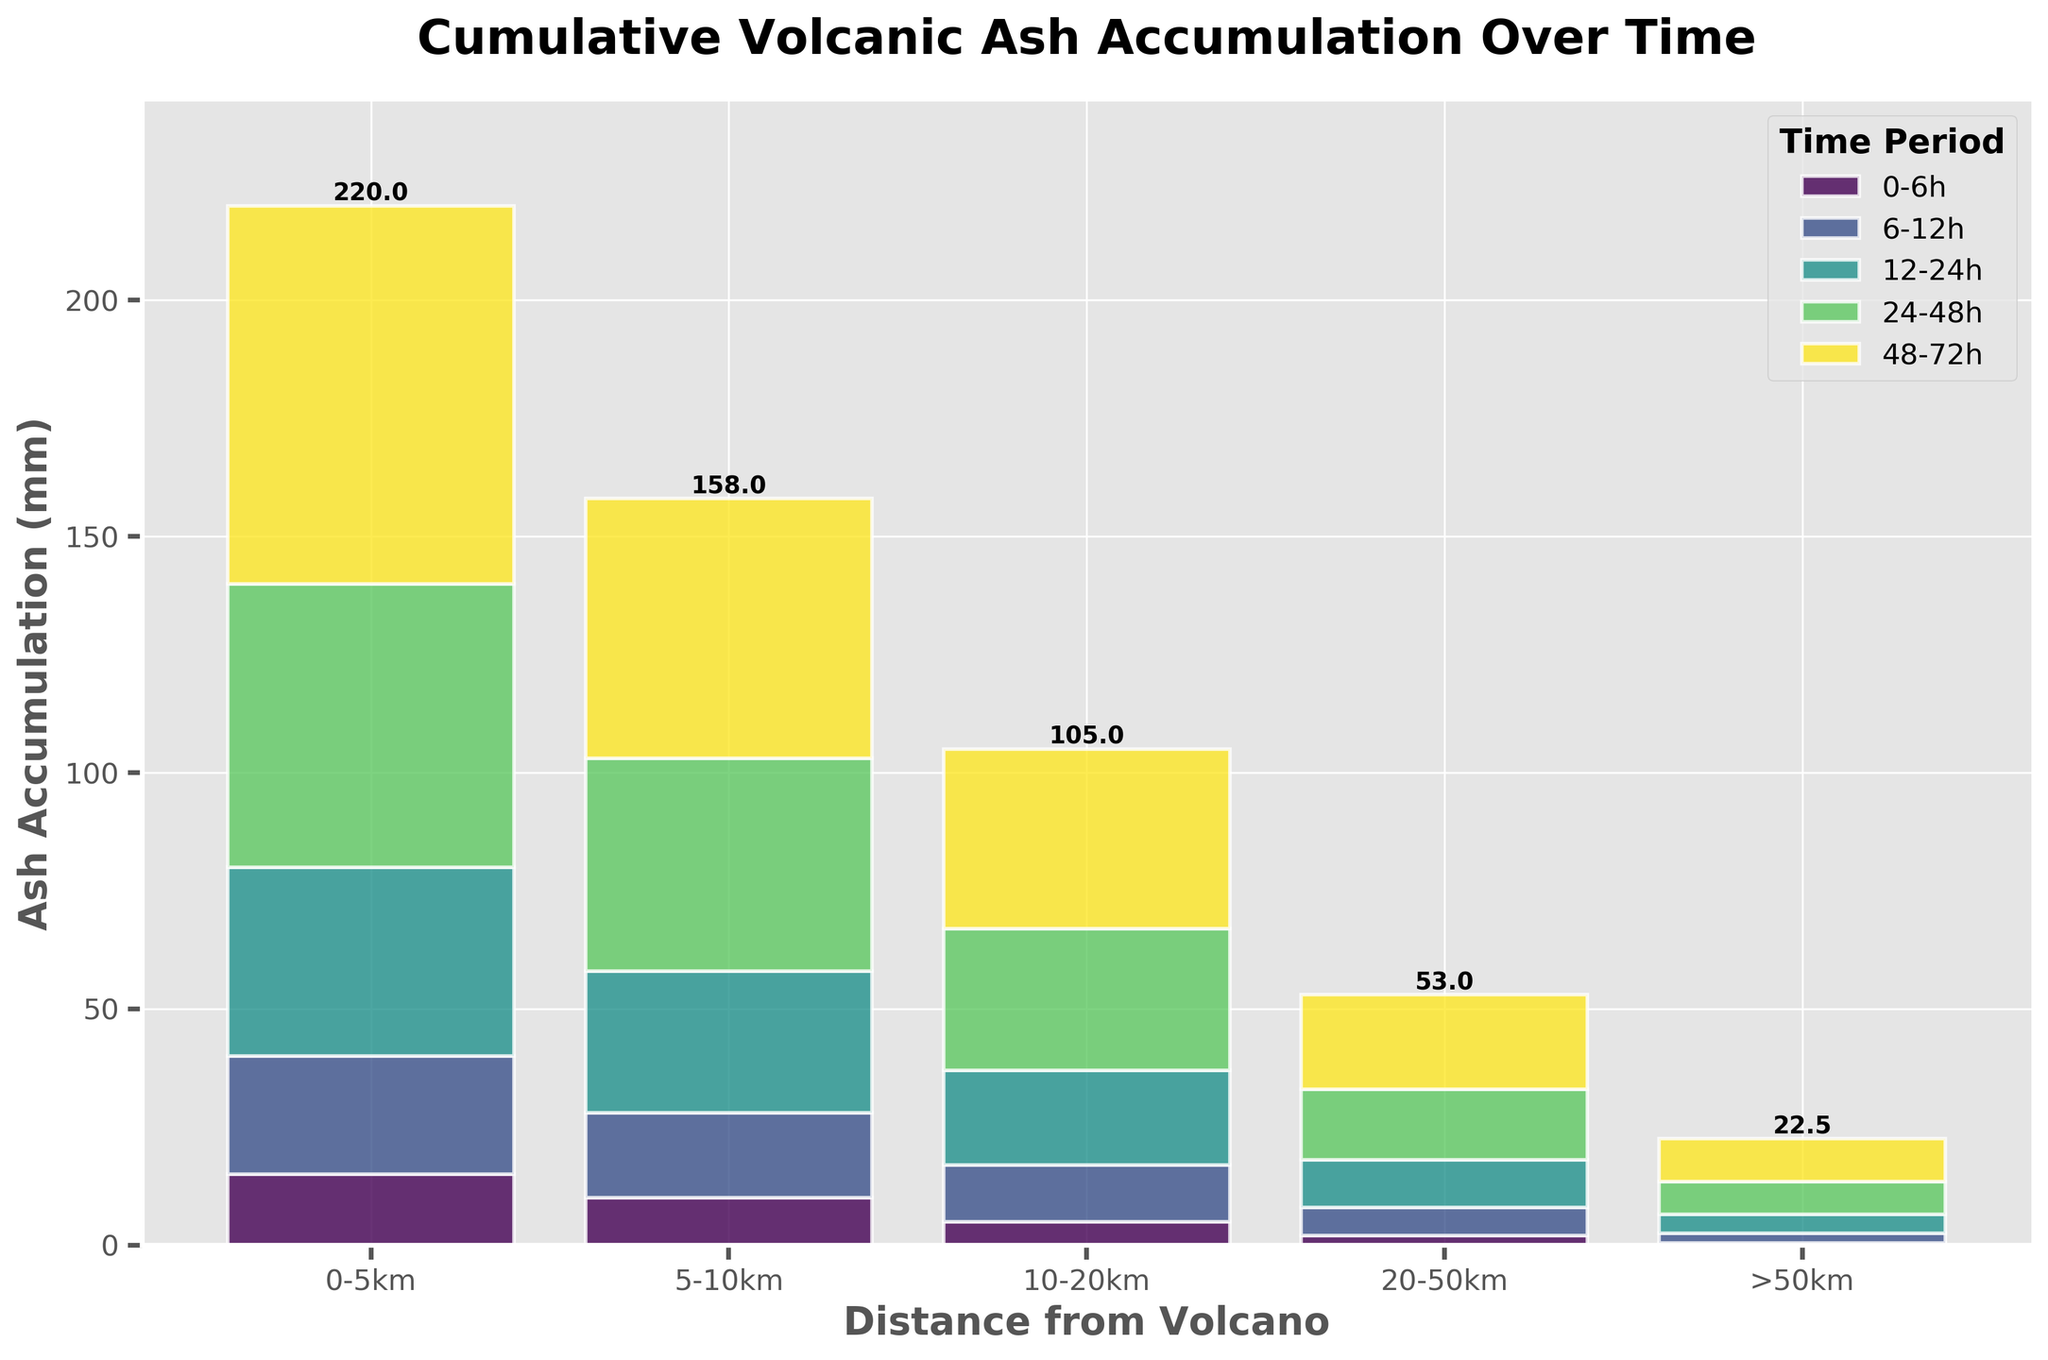What's the title of the chart? The title is displayed at the top of the chart. It summarizes what the chart is about.
Answer: Cumulative Volcanic Ash Accumulation Over Time What does the x-axis represent? The x-axis represents the different distance ranges from the volcano. These ranges are shown as 0-5km, 5-10km, 10-20km, 20-50km, and >50km.
Answer: Distance from Volcano What is the cumulative ash accumulation at a distance of 5-10km after 72 hours? To find this, add the heights of the bars in the 5-10km section for each time period (10 + 18 + 30 + 45 + 55).
Answer: 158mm Which distance range has the highest ash accumulation after 48 hours? Compare the top of the bars in the 48-hour time period for each distance range. The highest bar is in the 0-5km range.
Answer: 0-5km How much ash accumulation occurs between 5-10km from 24 to 48 hours? Look at the height of the bars for the 24-48 hours time period in the 5-10km section, which is 15mm.
Answer: 15mm What is the cumulative ash accumulation for the distance range of 20-50km by 24 hours? Sum the heights of the bars in the 20-50km section up to 24 hours, which is the sum of 2, 6, and 10.
Answer: 18mm How does the ash accumulation at 10-20km after 6 hours compare to after 12 hours? Observe the heights of the bars for the 10-20km section at 6 hours and 12 hours. At 6 hours, it's 5mm; at 12 hours, it's 12mm.
Answer: The accumulation at 12 hours is higher by 7mm By what factor does ash accumulation increase at 0-5km between 6-12 hours and 12-24 hours? Divide the ash accumulation at 12-24 hours by the accumulation at 6-12 hours for the 0-5km section (40/25).
Answer: 1.6 What is the difference in ash accumulation between 0-5km and >50km after 6-12 hours? Subtract the ash accumulation of >50km from 0-5km for the period 6-12 hours (25 - 2).
Answer: 23mm Which distance ranges are most affected by the eruption over time? Compare the total height of bars across all time periods for each distance range. The 0-5km and 5-10km ranges have the highest accumulations, indicating they are most affected.
Answer: 0-5km, 5-10km 